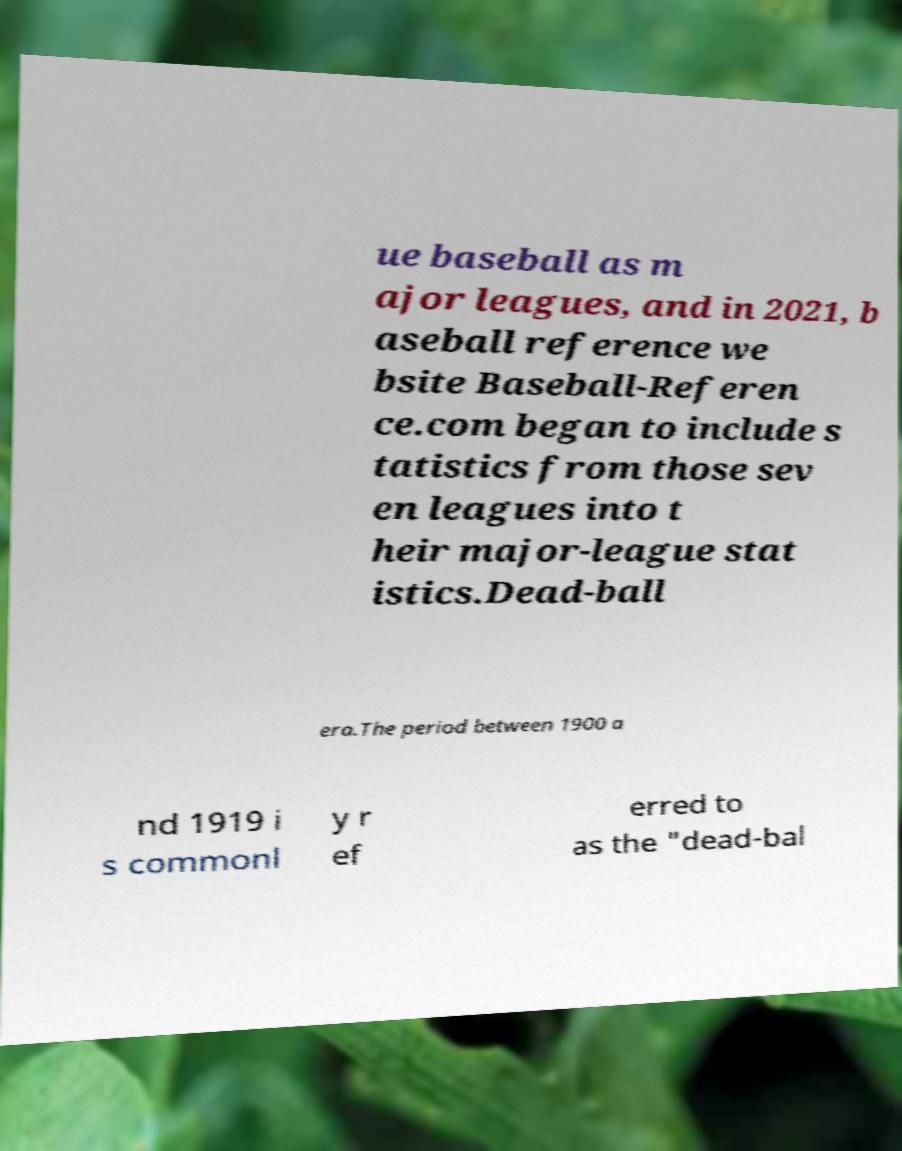Could you assist in decoding the text presented in this image and type it out clearly? ue baseball as m ajor leagues, and in 2021, b aseball reference we bsite Baseball-Referen ce.com began to include s tatistics from those sev en leagues into t heir major-league stat istics.Dead-ball era.The period between 1900 a nd 1919 i s commonl y r ef erred to as the "dead-bal 